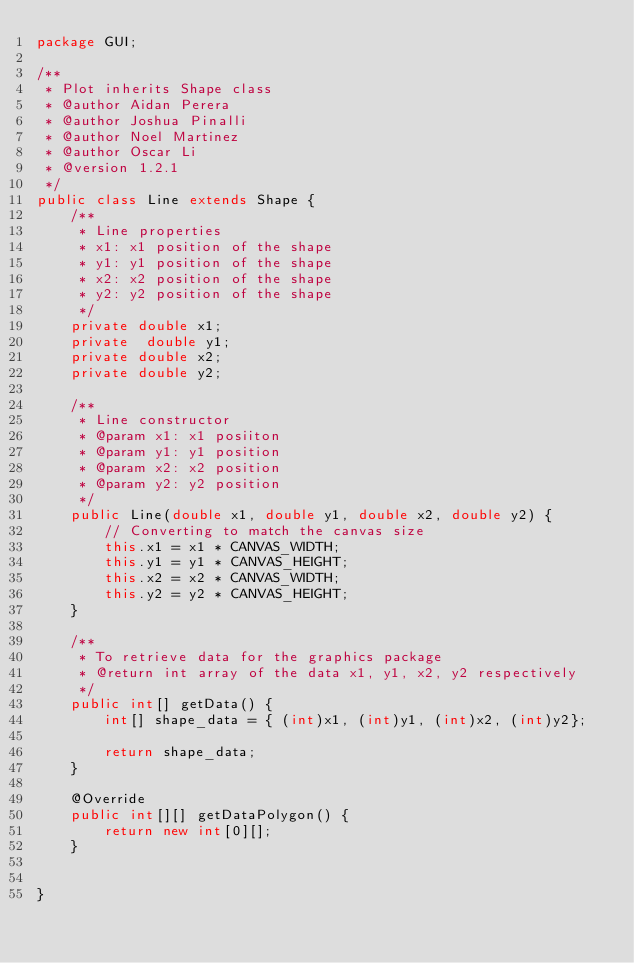<code> <loc_0><loc_0><loc_500><loc_500><_Java_>package GUI;

/**
 * Plot inherits Shape class
 * @author Aidan Perera
 * @author Joshua Pinalli
 * @author Noel Martinez
 * @author Oscar Li
 * @version 1.2.1
 */
public class Line extends Shape {
    /**
     * Line properties
     * x1: x1 position of the shape
     * y1: y1 position of the shape
     * x2: x2 position of the shape
     * y2: y2 position of the shape
     */
    private double x1;
    private  double y1;
    private double x2;
    private double y2;

    /**
     * Line constructor
     * @param x1: x1 posiiton
     * @param y1: y1 position
     * @param x2: x2 position
     * @param y2: y2 position
     */
    public Line(double x1, double y1, double x2, double y2) {
        // Converting to match the canvas size
        this.x1 = x1 * CANVAS_WIDTH;
        this.y1 = y1 * CANVAS_HEIGHT;
        this.x2 = x2 * CANVAS_WIDTH;
        this.y2 = y2 * CANVAS_HEIGHT;
    }

    /**
     * To retrieve data for the graphics package
     * @return int array of the data x1, y1, x2, y2 respectively
     */
    public int[] getData() {
        int[] shape_data = { (int)x1, (int)y1, (int)x2, (int)y2};

        return shape_data;
    }

    @Override
    public int[][] getDataPolygon() {
        return new int[0][];
    }


}
</code> 